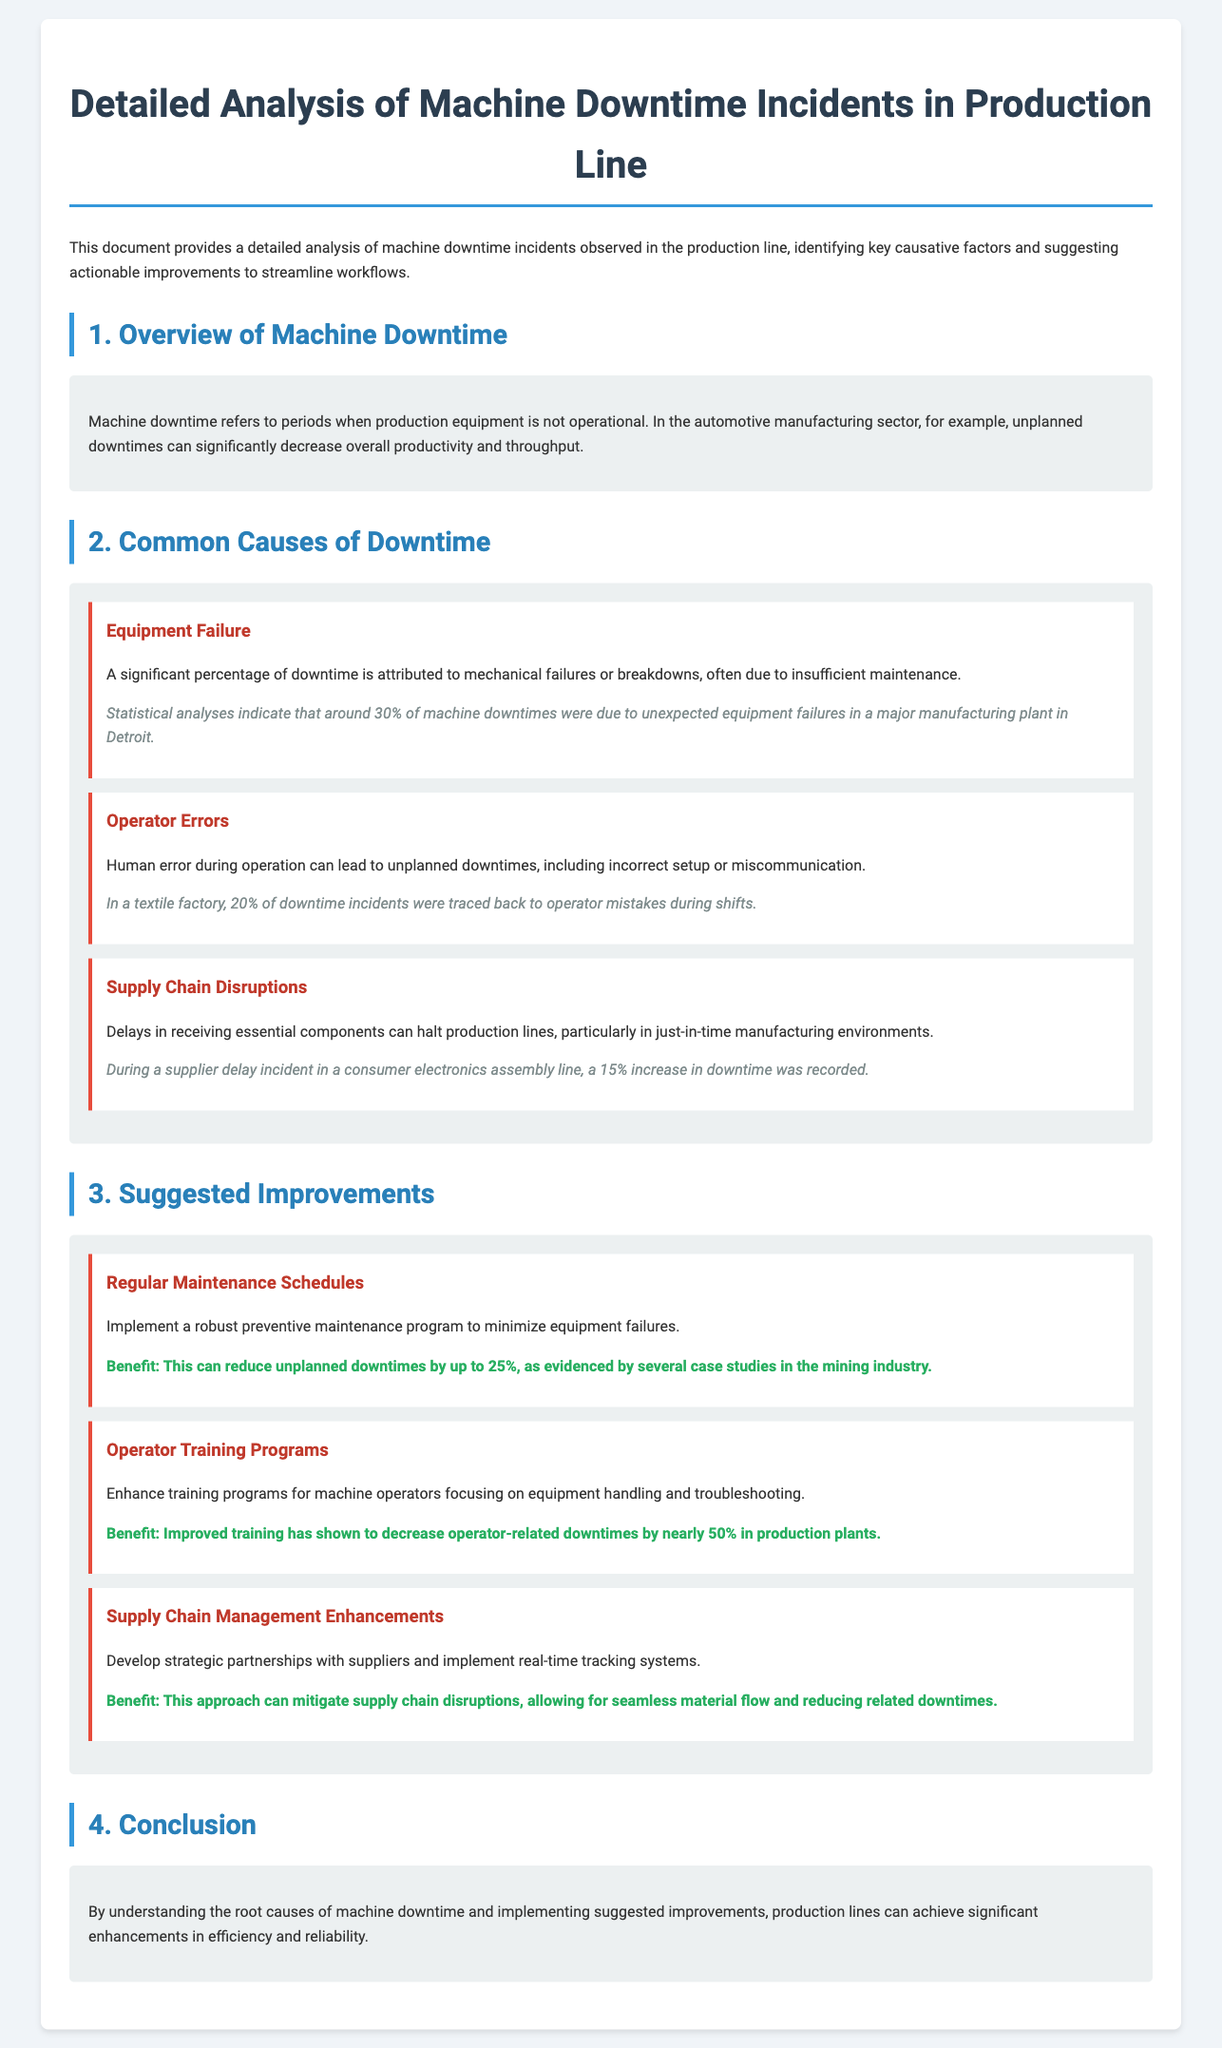What percentage of downtime is attributed to equipment failure? The document states that around 30% of machine downtimes were due to unexpected equipment failures.
Answer: 30% What is one reason for operator-related downtimes? According to the document, human error during operation leads to unplanned downtimes, including incorrect setup.
Answer: Incorrect setup What improvement can reduce unplanned downtimes by up to 25%? The document suggests implementing a robust preventive maintenance program.
Answer: Preventive maintenance program What percentage of downtime incidents were related to operator mistakes in a textile factory? The document notes that 20% of downtime incidents were traced back to operator mistakes during shifts.
Answer: 20% What can enhance training for machine operators? The document discusses the need to enhance training programs focusing on equipment handling and troubleshooting.
Answer: Equipment handling and troubleshooting What type of disruptions can halt production lines? Supply chain disruptions can halt production lines as mentioned in the document.
Answer: Supply chain disruptions What was the increase in downtime recorded due to a supplier delay? The document states that a 15% increase in downtime was recorded during a supplier delay incident.
Answer: 15% What approach can mitigate supply chain disruptions? Developing strategic partnerships with suppliers can mitigate supply chain disruptions as noted in the document.
Answer: Strategic partnerships What is one benefit of improved training for operators? Improved training has shown to decrease operator-related downtimes by nearly 50%.
Answer: Decrease by nearly 50% 